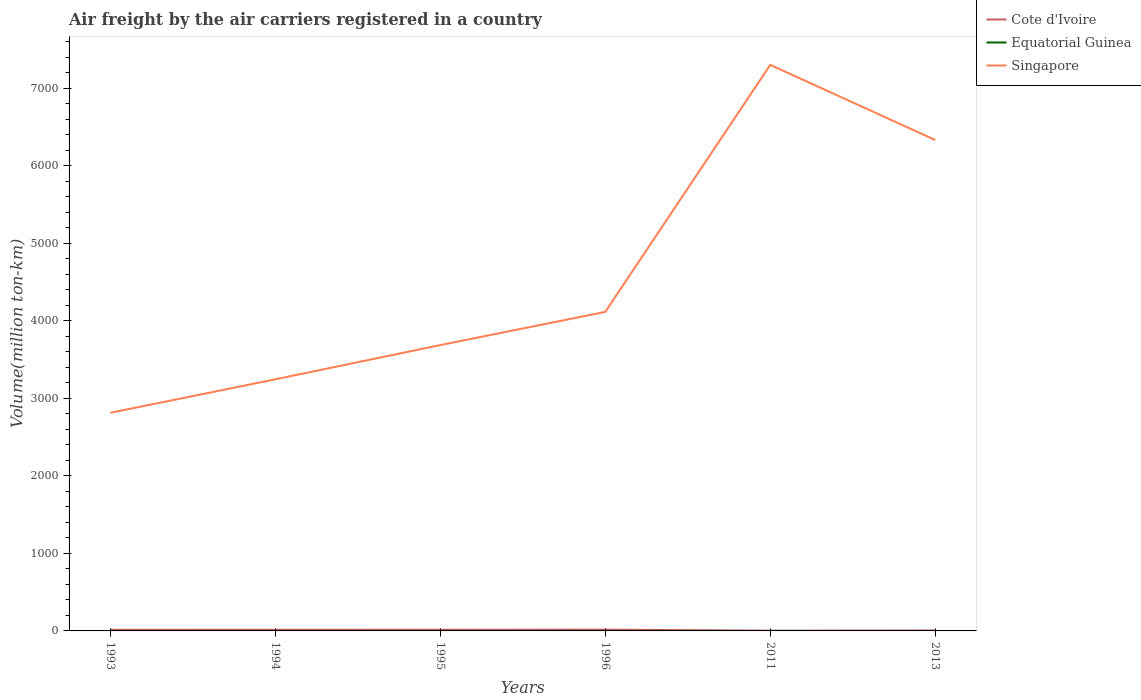How many different coloured lines are there?
Offer a very short reply. 3. Does the line corresponding to Cote d'Ivoire intersect with the line corresponding to Singapore?
Keep it short and to the point. No. Across all years, what is the maximum volume of the air carriers in Equatorial Guinea?
Offer a terse response. 0.1. In which year was the volume of the air carriers in Equatorial Guinea maximum?
Offer a very short reply. 1993. What is the total volume of the air carriers in Cote d'Ivoire in the graph?
Give a very brief answer. -2.2. What is the difference between the highest and the second highest volume of the air carriers in Cote d'Ivoire?
Your answer should be compact. 13.79. What is the difference between the highest and the lowest volume of the air carriers in Singapore?
Provide a short and direct response. 2. Is the volume of the air carriers in Equatorial Guinea strictly greater than the volume of the air carriers in Singapore over the years?
Your answer should be compact. Yes. How many years are there in the graph?
Make the answer very short. 6. Does the graph contain any zero values?
Offer a very short reply. No. Where does the legend appear in the graph?
Your response must be concise. Top right. How many legend labels are there?
Offer a very short reply. 3. What is the title of the graph?
Make the answer very short. Air freight by the air carriers registered in a country. What is the label or title of the Y-axis?
Your response must be concise. Volume(million ton-km). What is the Volume(million ton-km) in Cote d'Ivoire in 1993?
Offer a terse response. 14.3. What is the Volume(million ton-km) of Equatorial Guinea in 1993?
Offer a very short reply. 0.1. What is the Volume(million ton-km) of Singapore in 1993?
Your answer should be compact. 2813.4. What is the Volume(million ton-km) of Cote d'Ivoire in 1994?
Ensure brevity in your answer.  14.5. What is the Volume(million ton-km) of Equatorial Guinea in 1994?
Provide a succinct answer. 0.1. What is the Volume(million ton-km) in Singapore in 1994?
Make the answer very short. 3245. What is the Volume(million ton-km) of Cote d'Ivoire in 1995?
Ensure brevity in your answer.  15.3. What is the Volume(million ton-km) of Equatorial Guinea in 1995?
Offer a terse response. 0.1. What is the Volume(million ton-km) of Singapore in 1995?
Provide a short and direct response. 3686.9. What is the Volume(million ton-km) in Cote d'Ivoire in 1996?
Provide a short and direct response. 16.5. What is the Volume(million ton-km) in Equatorial Guinea in 1996?
Your answer should be very brief. 0.1. What is the Volume(million ton-km) in Singapore in 1996?
Keep it short and to the point. 4115. What is the Volume(million ton-km) of Cote d'Ivoire in 2011?
Provide a succinct answer. 2.71. What is the Volume(million ton-km) of Equatorial Guinea in 2011?
Ensure brevity in your answer.  0.23. What is the Volume(million ton-km) in Singapore in 2011?
Make the answer very short. 7300.8. What is the Volume(million ton-km) of Cote d'Ivoire in 2013?
Offer a very short reply. 4.56. What is the Volume(million ton-km) of Equatorial Guinea in 2013?
Offer a very short reply. 0.36. What is the Volume(million ton-km) in Singapore in 2013?
Ensure brevity in your answer.  6331.89. Across all years, what is the maximum Volume(million ton-km) in Cote d'Ivoire?
Provide a succinct answer. 16.5. Across all years, what is the maximum Volume(million ton-km) of Equatorial Guinea?
Keep it short and to the point. 0.36. Across all years, what is the maximum Volume(million ton-km) of Singapore?
Give a very brief answer. 7300.8. Across all years, what is the minimum Volume(million ton-km) in Cote d'Ivoire?
Your answer should be very brief. 2.71. Across all years, what is the minimum Volume(million ton-km) of Equatorial Guinea?
Ensure brevity in your answer.  0.1. Across all years, what is the minimum Volume(million ton-km) in Singapore?
Ensure brevity in your answer.  2813.4. What is the total Volume(million ton-km) in Cote d'Ivoire in the graph?
Your response must be concise. 67.87. What is the total Volume(million ton-km) of Equatorial Guinea in the graph?
Your response must be concise. 0.99. What is the total Volume(million ton-km) of Singapore in the graph?
Make the answer very short. 2.75e+04. What is the difference between the Volume(million ton-km) of Cote d'Ivoire in 1993 and that in 1994?
Provide a succinct answer. -0.2. What is the difference between the Volume(million ton-km) of Singapore in 1993 and that in 1994?
Your answer should be very brief. -431.6. What is the difference between the Volume(million ton-km) in Cote d'Ivoire in 1993 and that in 1995?
Provide a short and direct response. -1. What is the difference between the Volume(million ton-km) in Singapore in 1993 and that in 1995?
Your answer should be very brief. -873.5. What is the difference between the Volume(million ton-km) in Singapore in 1993 and that in 1996?
Give a very brief answer. -1301.6. What is the difference between the Volume(million ton-km) in Cote d'Ivoire in 1993 and that in 2011?
Your answer should be compact. 11.59. What is the difference between the Volume(million ton-km) of Equatorial Guinea in 1993 and that in 2011?
Offer a very short reply. -0.13. What is the difference between the Volume(million ton-km) in Singapore in 1993 and that in 2011?
Offer a terse response. -4487.4. What is the difference between the Volume(million ton-km) in Cote d'Ivoire in 1993 and that in 2013?
Your response must be concise. 9.74. What is the difference between the Volume(million ton-km) of Equatorial Guinea in 1993 and that in 2013?
Your answer should be compact. -0.26. What is the difference between the Volume(million ton-km) of Singapore in 1993 and that in 2013?
Your answer should be compact. -3518.49. What is the difference between the Volume(million ton-km) of Singapore in 1994 and that in 1995?
Give a very brief answer. -441.9. What is the difference between the Volume(million ton-km) of Cote d'Ivoire in 1994 and that in 1996?
Offer a very short reply. -2. What is the difference between the Volume(million ton-km) in Equatorial Guinea in 1994 and that in 1996?
Offer a terse response. 0. What is the difference between the Volume(million ton-km) in Singapore in 1994 and that in 1996?
Make the answer very short. -870. What is the difference between the Volume(million ton-km) of Cote d'Ivoire in 1994 and that in 2011?
Your answer should be very brief. 11.79. What is the difference between the Volume(million ton-km) in Equatorial Guinea in 1994 and that in 2011?
Your answer should be very brief. -0.13. What is the difference between the Volume(million ton-km) in Singapore in 1994 and that in 2011?
Provide a succinct answer. -4055.8. What is the difference between the Volume(million ton-km) in Cote d'Ivoire in 1994 and that in 2013?
Offer a very short reply. 9.94. What is the difference between the Volume(million ton-km) of Equatorial Guinea in 1994 and that in 2013?
Ensure brevity in your answer.  -0.26. What is the difference between the Volume(million ton-km) in Singapore in 1994 and that in 2013?
Make the answer very short. -3086.89. What is the difference between the Volume(million ton-km) of Equatorial Guinea in 1995 and that in 1996?
Give a very brief answer. 0. What is the difference between the Volume(million ton-km) in Singapore in 1995 and that in 1996?
Provide a succinct answer. -428.1. What is the difference between the Volume(million ton-km) of Cote d'Ivoire in 1995 and that in 2011?
Keep it short and to the point. 12.59. What is the difference between the Volume(million ton-km) of Equatorial Guinea in 1995 and that in 2011?
Offer a very short reply. -0.13. What is the difference between the Volume(million ton-km) of Singapore in 1995 and that in 2011?
Offer a very short reply. -3613.9. What is the difference between the Volume(million ton-km) of Cote d'Ivoire in 1995 and that in 2013?
Offer a very short reply. 10.74. What is the difference between the Volume(million ton-km) of Equatorial Guinea in 1995 and that in 2013?
Your response must be concise. -0.26. What is the difference between the Volume(million ton-km) in Singapore in 1995 and that in 2013?
Offer a very short reply. -2644.99. What is the difference between the Volume(million ton-km) in Cote d'Ivoire in 1996 and that in 2011?
Your response must be concise. 13.79. What is the difference between the Volume(million ton-km) of Equatorial Guinea in 1996 and that in 2011?
Make the answer very short. -0.13. What is the difference between the Volume(million ton-km) in Singapore in 1996 and that in 2011?
Your answer should be very brief. -3185.8. What is the difference between the Volume(million ton-km) in Cote d'Ivoire in 1996 and that in 2013?
Provide a succinct answer. 11.94. What is the difference between the Volume(million ton-km) of Equatorial Guinea in 1996 and that in 2013?
Provide a short and direct response. -0.26. What is the difference between the Volume(million ton-km) of Singapore in 1996 and that in 2013?
Offer a very short reply. -2216.89. What is the difference between the Volume(million ton-km) in Cote d'Ivoire in 2011 and that in 2013?
Your response must be concise. -1.86. What is the difference between the Volume(million ton-km) of Equatorial Guinea in 2011 and that in 2013?
Provide a succinct answer. -0.14. What is the difference between the Volume(million ton-km) of Singapore in 2011 and that in 2013?
Keep it short and to the point. 968.91. What is the difference between the Volume(million ton-km) in Cote d'Ivoire in 1993 and the Volume(million ton-km) in Equatorial Guinea in 1994?
Your answer should be compact. 14.2. What is the difference between the Volume(million ton-km) of Cote d'Ivoire in 1993 and the Volume(million ton-km) of Singapore in 1994?
Provide a short and direct response. -3230.7. What is the difference between the Volume(million ton-km) of Equatorial Guinea in 1993 and the Volume(million ton-km) of Singapore in 1994?
Provide a short and direct response. -3244.9. What is the difference between the Volume(million ton-km) of Cote d'Ivoire in 1993 and the Volume(million ton-km) of Singapore in 1995?
Your answer should be very brief. -3672.6. What is the difference between the Volume(million ton-km) of Equatorial Guinea in 1993 and the Volume(million ton-km) of Singapore in 1995?
Your answer should be compact. -3686.8. What is the difference between the Volume(million ton-km) of Cote d'Ivoire in 1993 and the Volume(million ton-km) of Singapore in 1996?
Offer a terse response. -4100.7. What is the difference between the Volume(million ton-km) in Equatorial Guinea in 1993 and the Volume(million ton-km) in Singapore in 1996?
Ensure brevity in your answer.  -4114.9. What is the difference between the Volume(million ton-km) in Cote d'Ivoire in 1993 and the Volume(million ton-km) in Equatorial Guinea in 2011?
Your answer should be very brief. 14.07. What is the difference between the Volume(million ton-km) of Cote d'Ivoire in 1993 and the Volume(million ton-km) of Singapore in 2011?
Offer a very short reply. -7286.5. What is the difference between the Volume(million ton-km) in Equatorial Guinea in 1993 and the Volume(million ton-km) in Singapore in 2011?
Make the answer very short. -7300.7. What is the difference between the Volume(million ton-km) in Cote d'Ivoire in 1993 and the Volume(million ton-km) in Equatorial Guinea in 2013?
Make the answer very short. 13.94. What is the difference between the Volume(million ton-km) of Cote d'Ivoire in 1993 and the Volume(million ton-km) of Singapore in 2013?
Make the answer very short. -6317.59. What is the difference between the Volume(million ton-km) in Equatorial Guinea in 1993 and the Volume(million ton-km) in Singapore in 2013?
Your answer should be compact. -6331.79. What is the difference between the Volume(million ton-km) of Cote d'Ivoire in 1994 and the Volume(million ton-km) of Singapore in 1995?
Ensure brevity in your answer.  -3672.4. What is the difference between the Volume(million ton-km) of Equatorial Guinea in 1994 and the Volume(million ton-km) of Singapore in 1995?
Your response must be concise. -3686.8. What is the difference between the Volume(million ton-km) in Cote d'Ivoire in 1994 and the Volume(million ton-km) in Singapore in 1996?
Provide a succinct answer. -4100.5. What is the difference between the Volume(million ton-km) of Equatorial Guinea in 1994 and the Volume(million ton-km) of Singapore in 1996?
Provide a succinct answer. -4114.9. What is the difference between the Volume(million ton-km) in Cote d'Ivoire in 1994 and the Volume(million ton-km) in Equatorial Guinea in 2011?
Provide a short and direct response. 14.27. What is the difference between the Volume(million ton-km) of Cote d'Ivoire in 1994 and the Volume(million ton-km) of Singapore in 2011?
Your response must be concise. -7286.3. What is the difference between the Volume(million ton-km) in Equatorial Guinea in 1994 and the Volume(million ton-km) in Singapore in 2011?
Ensure brevity in your answer.  -7300.7. What is the difference between the Volume(million ton-km) in Cote d'Ivoire in 1994 and the Volume(million ton-km) in Equatorial Guinea in 2013?
Offer a terse response. 14.14. What is the difference between the Volume(million ton-km) of Cote d'Ivoire in 1994 and the Volume(million ton-km) of Singapore in 2013?
Make the answer very short. -6317.39. What is the difference between the Volume(million ton-km) in Equatorial Guinea in 1994 and the Volume(million ton-km) in Singapore in 2013?
Your answer should be compact. -6331.79. What is the difference between the Volume(million ton-km) in Cote d'Ivoire in 1995 and the Volume(million ton-km) in Singapore in 1996?
Ensure brevity in your answer.  -4099.7. What is the difference between the Volume(million ton-km) in Equatorial Guinea in 1995 and the Volume(million ton-km) in Singapore in 1996?
Provide a short and direct response. -4114.9. What is the difference between the Volume(million ton-km) of Cote d'Ivoire in 1995 and the Volume(million ton-km) of Equatorial Guinea in 2011?
Your answer should be compact. 15.07. What is the difference between the Volume(million ton-km) of Cote d'Ivoire in 1995 and the Volume(million ton-km) of Singapore in 2011?
Ensure brevity in your answer.  -7285.5. What is the difference between the Volume(million ton-km) in Equatorial Guinea in 1995 and the Volume(million ton-km) in Singapore in 2011?
Provide a succinct answer. -7300.7. What is the difference between the Volume(million ton-km) in Cote d'Ivoire in 1995 and the Volume(million ton-km) in Equatorial Guinea in 2013?
Your answer should be compact. 14.94. What is the difference between the Volume(million ton-km) in Cote d'Ivoire in 1995 and the Volume(million ton-km) in Singapore in 2013?
Offer a terse response. -6316.59. What is the difference between the Volume(million ton-km) in Equatorial Guinea in 1995 and the Volume(million ton-km) in Singapore in 2013?
Keep it short and to the point. -6331.79. What is the difference between the Volume(million ton-km) in Cote d'Ivoire in 1996 and the Volume(million ton-km) in Equatorial Guinea in 2011?
Keep it short and to the point. 16.27. What is the difference between the Volume(million ton-km) of Cote d'Ivoire in 1996 and the Volume(million ton-km) of Singapore in 2011?
Give a very brief answer. -7284.3. What is the difference between the Volume(million ton-km) in Equatorial Guinea in 1996 and the Volume(million ton-km) in Singapore in 2011?
Ensure brevity in your answer.  -7300.7. What is the difference between the Volume(million ton-km) in Cote d'Ivoire in 1996 and the Volume(million ton-km) in Equatorial Guinea in 2013?
Your response must be concise. 16.14. What is the difference between the Volume(million ton-km) of Cote d'Ivoire in 1996 and the Volume(million ton-km) of Singapore in 2013?
Keep it short and to the point. -6315.39. What is the difference between the Volume(million ton-km) in Equatorial Guinea in 1996 and the Volume(million ton-km) in Singapore in 2013?
Offer a very short reply. -6331.79. What is the difference between the Volume(million ton-km) in Cote d'Ivoire in 2011 and the Volume(million ton-km) in Equatorial Guinea in 2013?
Your answer should be very brief. 2.35. What is the difference between the Volume(million ton-km) in Cote d'Ivoire in 2011 and the Volume(million ton-km) in Singapore in 2013?
Provide a succinct answer. -6329.18. What is the difference between the Volume(million ton-km) of Equatorial Guinea in 2011 and the Volume(million ton-km) of Singapore in 2013?
Offer a terse response. -6331.66. What is the average Volume(million ton-km) of Cote d'Ivoire per year?
Provide a succinct answer. 11.31. What is the average Volume(million ton-km) of Equatorial Guinea per year?
Offer a terse response. 0.16. What is the average Volume(million ton-km) of Singapore per year?
Give a very brief answer. 4582.16. In the year 1993, what is the difference between the Volume(million ton-km) of Cote d'Ivoire and Volume(million ton-km) of Equatorial Guinea?
Keep it short and to the point. 14.2. In the year 1993, what is the difference between the Volume(million ton-km) of Cote d'Ivoire and Volume(million ton-km) of Singapore?
Your answer should be compact. -2799.1. In the year 1993, what is the difference between the Volume(million ton-km) in Equatorial Guinea and Volume(million ton-km) in Singapore?
Provide a short and direct response. -2813.3. In the year 1994, what is the difference between the Volume(million ton-km) of Cote d'Ivoire and Volume(million ton-km) of Singapore?
Make the answer very short. -3230.5. In the year 1994, what is the difference between the Volume(million ton-km) of Equatorial Guinea and Volume(million ton-km) of Singapore?
Provide a short and direct response. -3244.9. In the year 1995, what is the difference between the Volume(million ton-km) in Cote d'Ivoire and Volume(million ton-km) in Equatorial Guinea?
Provide a short and direct response. 15.2. In the year 1995, what is the difference between the Volume(million ton-km) in Cote d'Ivoire and Volume(million ton-km) in Singapore?
Offer a very short reply. -3671.6. In the year 1995, what is the difference between the Volume(million ton-km) of Equatorial Guinea and Volume(million ton-km) of Singapore?
Your response must be concise. -3686.8. In the year 1996, what is the difference between the Volume(million ton-km) in Cote d'Ivoire and Volume(million ton-km) in Equatorial Guinea?
Provide a short and direct response. 16.4. In the year 1996, what is the difference between the Volume(million ton-km) of Cote d'Ivoire and Volume(million ton-km) of Singapore?
Ensure brevity in your answer.  -4098.5. In the year 1996, what is the difference between the Volume(million ton-km) in Equatorial Guinea and Volume(million ton-km) in Singapore?
Your answer should be very brief. -4114.9. In the year 2011, what is the difference between the Volume(million ton-km) of Cote d'Ivoire and Volume(million ton-km) of Equatorial Guinea?
Provide a short and direct response. 2.48. In the year 2011, what is the difference between the Volume(million ton-km) of Cote d'Ivoire and Volume(million ton-km) of Singapore?
Your response must be concise. -7298.09. In the year 2011, what is the difference between the Volume(million ton-km) in Equatorial Guinea and Volume(million ton-km) in Singapore?
Make the answer very short. -7300.57. In the year 2013, what is the difference between the Volume(million ton-km) of Cote d'Ivoire and Volume(million ton-km) of Equatorial Guinea?
Offer a terse response. 4.2. In the year 2013, what is the difference between the Volume(million ton-km) of Cote d'Ivoire and Volume(million ton-km) of Singapore?
Your answer should be compact. -6327.32. In the year 2013, what is the difference between the Volume(million ton-km) of Equatorial Guinea and Volume(million ton-km) of Singapore?
Offer a terse response. -6331.53. What is the ratio of the Volume(million ton-km) in Cote d'Ivoire in 1993 to that in 1994?
Make the answer very short. 0.99. What is the ratio of the Volume(million ton-km) of Equatorial Guinea in 1993 to that in 1994?
Your answer should be very brief. 1. What is the ratio of the Volume(million ton-km) in Singapore in 1993 to that in 1994?
Your response must be concise. 0.87. What is the ratio of the Volume(million ton-km) in Cote d'Ivoire in 1993 to that in 1995?
Your answer should be compact. 0.93. What is the ratio of the Volume(million ton-km) in Equatorial Guinea in 1993 to that in 1995?
Your answer should be very brief. 1. What is the ratio of the Volume(million ton-km) of Singapore in 1993 to that in 1995?
Provide a short and direct response. 0.76. What is the ratio of the Volume(million ton-km) of Cote d'Ivoire in 1993 to that in 1996?
Offer a terse response. 0.87. What is the ratio of the Volume(million ton-km) of Equatorial Guinea in 1993 to that in 1996?
Make the answer very short. 1. What is the ratio of the Volume(million ton-km) of Singapore in 1993 to that in 1996?
Ensure brevity in your answer.  0.68. What is the ratio of the Volume(million ton-km) of Cote d'Ivoire in 1993 to that in 2011?
Provide a succinct answer. 5.28. What is the ratio of the Volume(million ton-km) of Equatorial Guinea in 1993 to that in 2011?
Ensure brevity in your answer.  0.44. What is the ratio of the Volume(million ton-km) of Singapore in 1993 to that in 2011?
Make the answer very short. 0.39. What is the ratio of the Volume(million ton-km) of Cote d'Ivoire in 1993 to that in 2013?
Make the answer very short. 3.13. What is the ratio of the Volume(million ton-km) in Equatorial Guinea in 1993 to that in 2013?
Keep it short and to the point. 0.28. What is the ratio of the Volume(million ton-km) in Singapore in 1993 to that in 2013?
Offer a very short reply. 0.44. What is the ratio of the Volume(million ton-km) of Cote d'Ivoire in 1994 to that in 1995?
Your answer should be very brief. 0.95. What is the ratio of the Volume(million ton-km) in Equatorial Guinea in 1994 to that in 1995?
Your response must be concise. 1. What is the ratio of the Volume(million ton-km) in Singapore in 1994 to that in 1995?
Make the answer very short. 0.88. What is the ratio of the Volume(million ton-km) of Cote d'Ivoire in 1994 to that in 1996?
Give a very brief answer. 0.88. What is the ratio of the Volume(million ton-km) in Singapore in 1994 to that in 1996?
Offer a terse response. 0.79. What is the ratio of the Volume(million ton-km) in Cote d'Ivoire in 1994 to that in 2011?
Ensure brevity in your answer.  5.35. What is the ratio of the Volume(million ton-km) in Equatorial Guinea in 1994 to that in 2011?
Your answer should be very brief. 0.44. What is the ratio of the Volume(million ton-km) of Singapore in 1994 to that in 2011?
Ensure brevity in your answer.  0.44. What is the ratio of the Volume(million ton-km) of Cote d'Ivoire in 1994 to that in 2013?
Make the answer very short. 3.18. What is the ratio of the Volume(million ton-km) in Equatorial Guinea in 1994 to that in 2013?
Make the answer very short. 0.28. What is the ratio of the Volume(million ton-km) in Singapore in 1994 to that in 2013?
Your answer should be very brief. 0.51. What is the ratio of the Volume(million ton-km) of Cote d'Ivoire in 1995 to that in 1996?
Your response must be concise. 0.93. What is the ratio of the Volume(million ton-km) of Equatorial Guinea in 1995 to that in 1996?
Your answer should be very brief. 1. What is the ratio of the Volume(million ton-km) in Singapore in 1995 to that in 1996?
Your answer should be very brief. 0.9. What is the ratio of the Volume(million ton-km) in Cote d'Ivoire in 1995 to that in 2011?
Provide a succinct answer. 5.65. What is the ratio of the Volume(million ton-km) in Equatorial Guinea in 1995 to that in 2011?
Give a very brief answer. 0.44. What is the ratio of the Volume(million ton-km) in Singapore in 1995 to that in 2011?
Offer a terse response. 0.51. What is the ratio of the Volume(million ton-km) in Cote d'Ivoire in 1995 to that in 2013?
Provide a short and direct response. 3.35. What is the ratio of the Volume(million ton-km) of Equatorial Guinea in 1995 to that in 2013?
Offer a terse response. 0.28. What is the ratio of the Volume(million ton-km) of Singapore in 1995 to that in 2013?
Offer a terse response. 0.58. What is the ratio of the Volume(million ton-km) in Cote d'Ivoire in 1996 to that in 2011?
Provide a short and direct response. 6.09. What is the ratio of the Volume(million ton-km) of Equatorial Guinea in 1996 to that in 2011?
Keep it short and to the point. 0.44. What is the ratio of the Volume(million ton-km) of Singapore in 1996 to that in 2011?
Your answer should be compact. 0.56. What is the ratio of the Volume(million ton-km) in Cote d'Ivoire in 1996 to that in 2013?
Provide a short and direct response. 3.62. What is the ratio of the Volume(million ton-km) of Equatorial Guinea in 1996 to that in 2013?
Keep it short and to the point. 0.28. What is the ratio of the Volume(million ton-km) in Singapore in 1996 to that in 2013?
Keep it short and to the point. 0.65. What is the ratio of the Volume(million ton-km) in Cote d'Ivoire in 2011 to that in 2013?
Offer a very short reply. 0.59. What is the ratio of the Volume(million ton-km) in Equatorial Guinea in 2011 to that in 2013?
Offer a terse response. 0.62. What is the ratio of the Volume(million ton-km) in Singapore in 2011 to that in 2013?
Your answer should be very brief. 1.15. What is the difference between the highest and the second highest Volume(million ton-km) in Equatorial Guinea?
Offer a terse response. 0.14. What is the difference between the highest and the second highest Volume(million ton-km) in Singapore?
Offer a very short reply. 968.91. What is the difference between the highest and the lowest Volume(million ton-km) of Cote d'Ivoire?
Your answer should be very brief. 13.79. What is the difference between the highest and the lowest Volume(million ton-km) of Equatorial Guinea?
Your answer should be compact. 0.26. What is the difference between the highest and the lowest Volume(million ton-km) in Singapore?
Keep it short and to the point. 4487.4. 